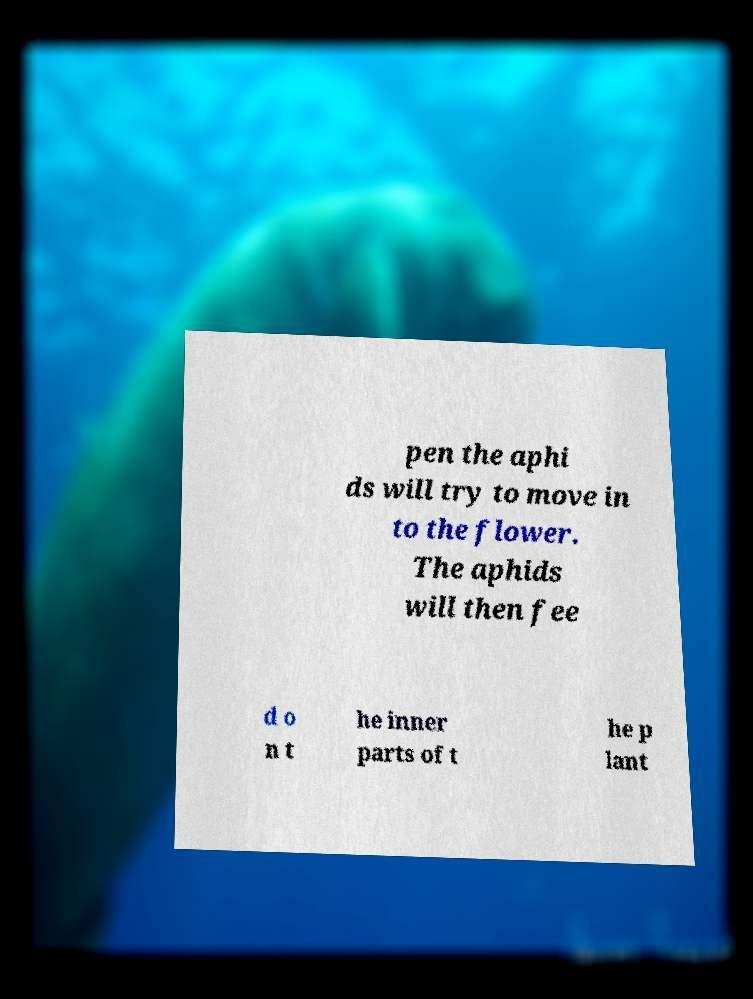Please identify and transcribe the text found in this image. pen the aphi ds will try to move in to the flower. The aphids will then fee d o n t he inner parts of t he p lant 